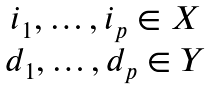<formula> <loc_0><loc_0><loc_500><loc_500>\begin{matrix} i _ { 1 } , \dots , i _ { p } \in X \\ d _ { 1 } , \dots , d _ { p } \in Y \end{matrix}</formula> 